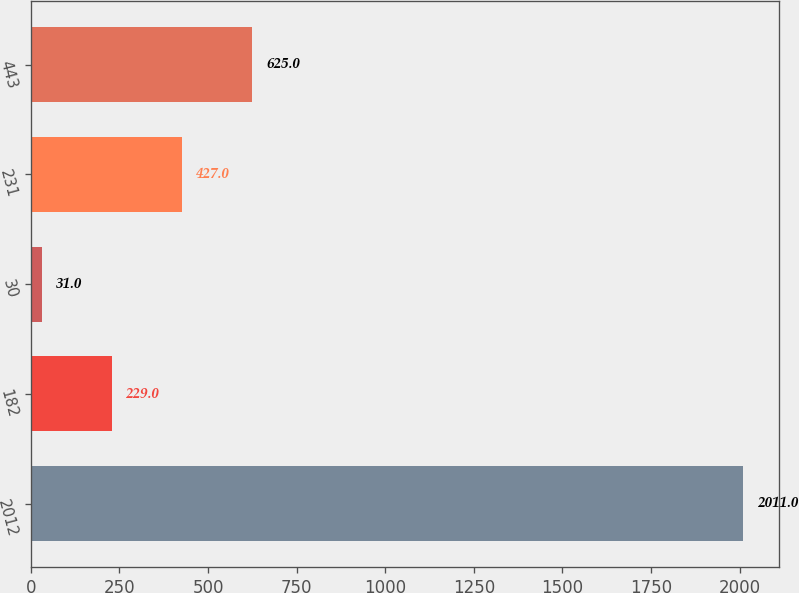Convert chart. <chart><loc_0><loc_0><loc_500><loc_500><bar_chart><fcel>2012<fcel>182<fcel>30<fcel>231<fcel>443<nl><fcel>2011<fcel>229<fcel>31<fcel>427<fcel>625<nl></chart> 